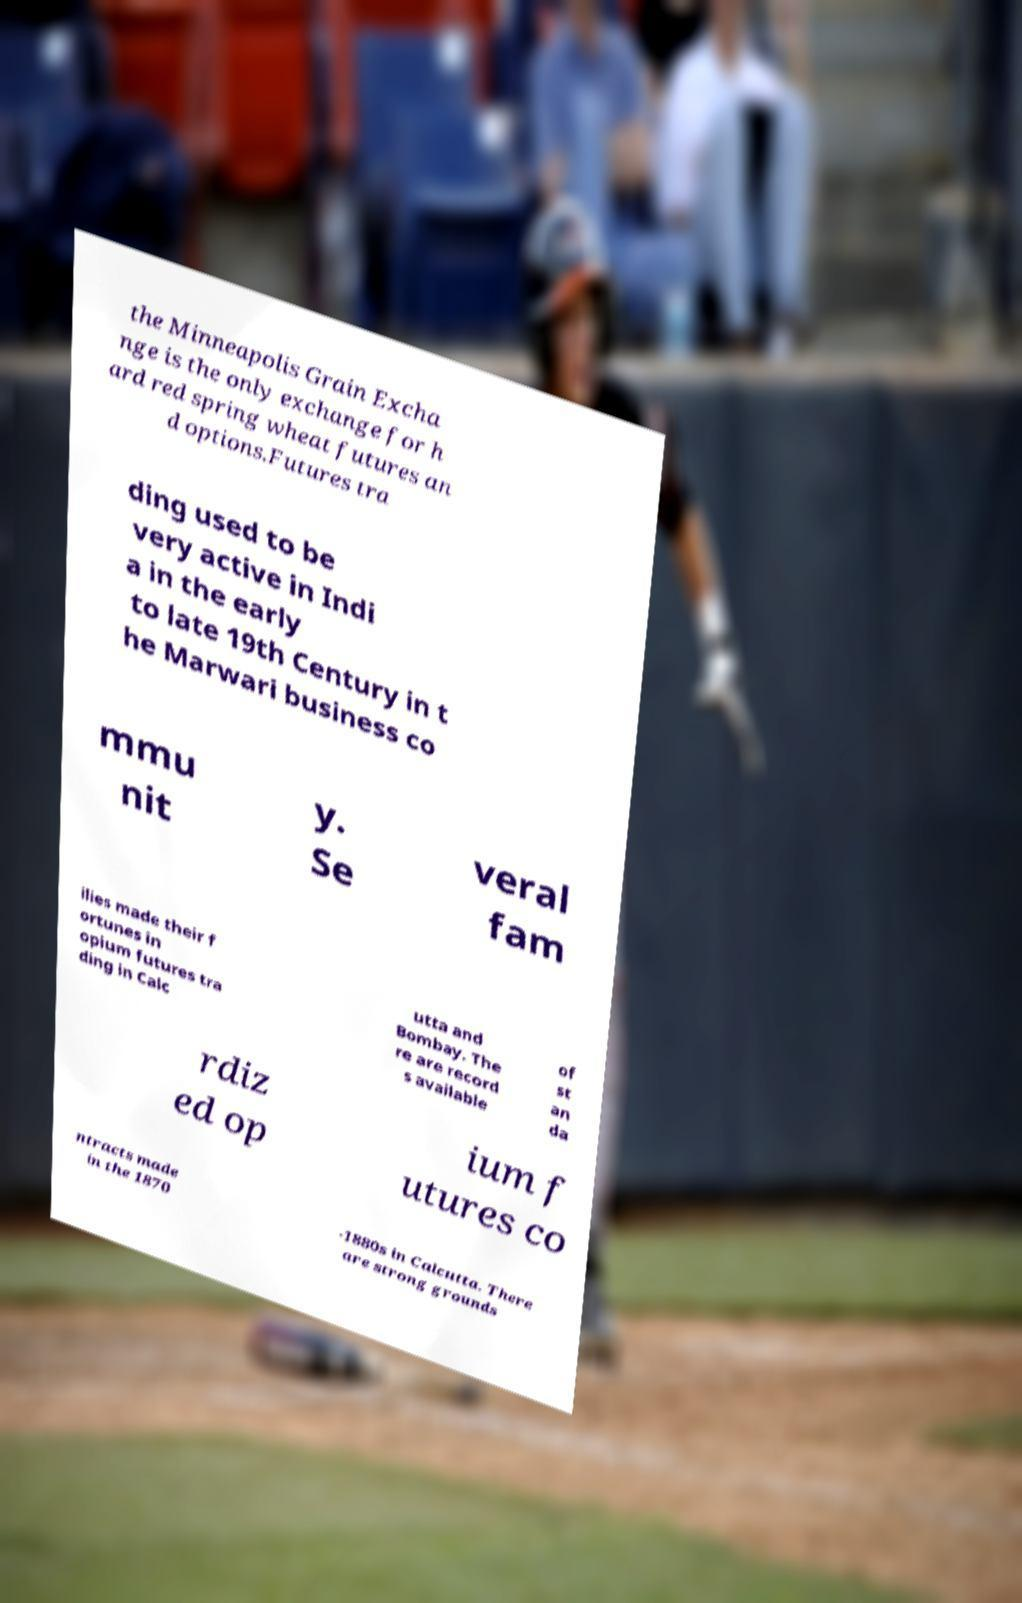Can you read and provide the text displayed in the image?This photo seems to have some interesting text. Can you extract and type it out for me? the Minneapolis Grain Excha nge is the only exchange for h ard red spring wheat futures an d options.Futures tra ding used to be very active in Indi a in the early to late 19th Century in t he Marwari business co mmu nit y. Se veral fam ilies made their f ortunes in opium futures tra ding in Calc utta and Bombay. The re are record s available of st an da rdiz ed op ium f utures co ntracts made in the 1870 -1880s in Calcutta. There are strong grounds 